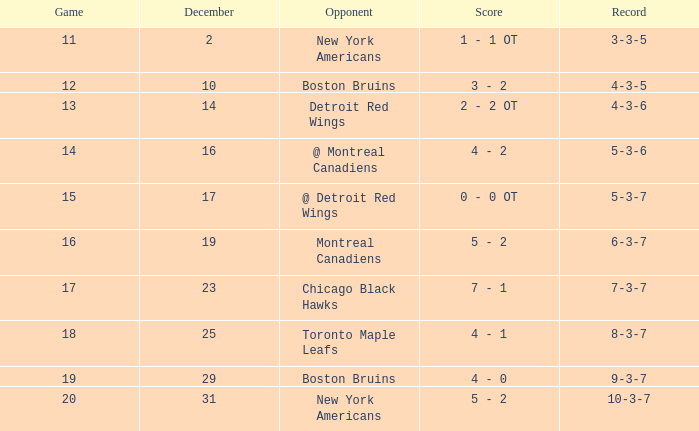Which score features a december smaller than 14, and a game equal to 12? 3 - 2. 